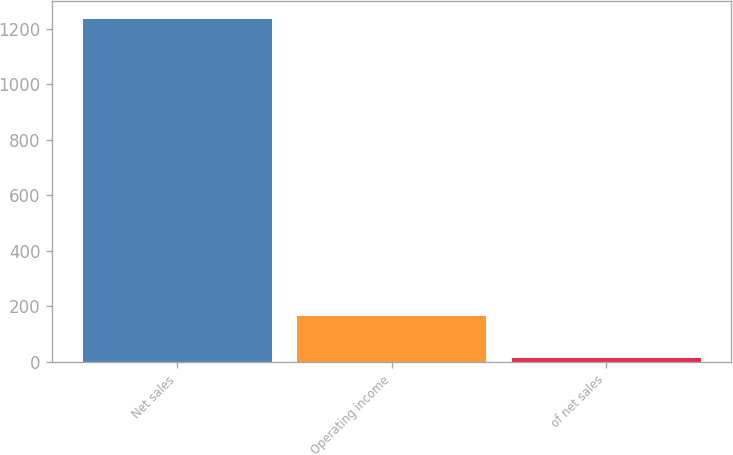Convert chart. <chart><loc_0><loc_0><loc_500><loc_500><bar_chart><fcel>Net sales<fcel>Operating income<fcel>of net sales<nl><fcel>1236.4<fcel>165<fcel>13.3<nl></chart> 